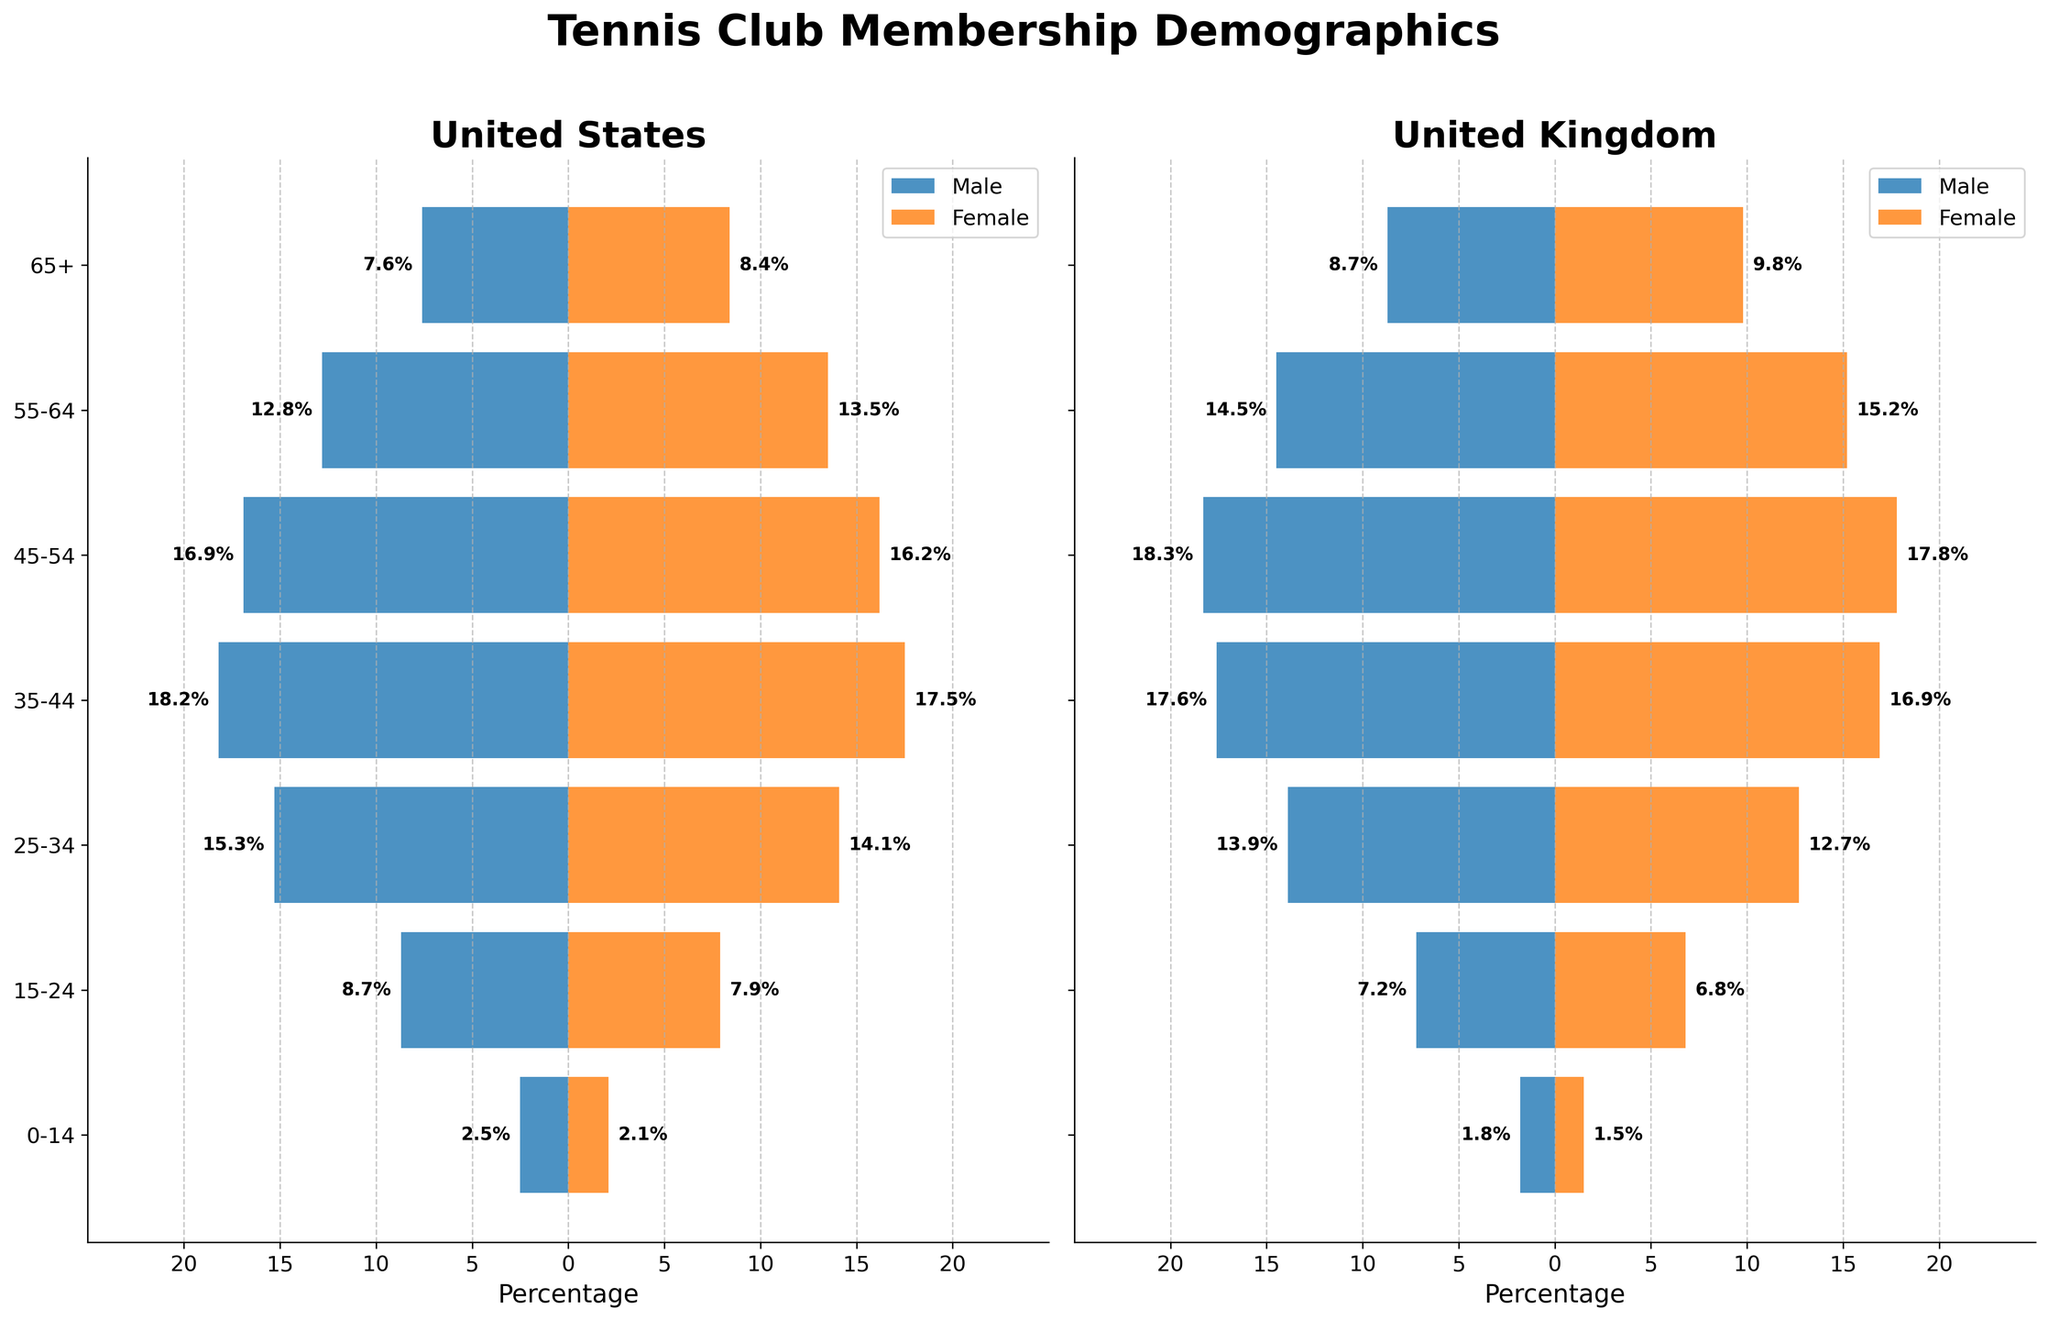What's the title of the figure? The title of the figure is located at the top center of the plot. It reads "Tennis Club Membership Demographics".
Answer: Tennis Club Membership Demographics Which country has a higher percentage of female members in the age group 35-44? To find the answer, compare the percentage of female members aged 35-44 in the United States and the United Kingdom. The United States has 17.5%, and the United Kingdom has 16.9%.
Answer: United States What is the total percentage of male and female tennis club members aged 45-54 in the United States? Add the percentages of male (16.9%) and female (16.2%) members aged 45-54. The total is 16.9 + 16.2 = 33.1.
Answer: 33.1% What is the difference in the percentage of male members aged 15-24 between the United States and the United Kingdom? Subtract the percentage of male members aged 15-24 in the United Kingdom (7.2%) from that in the United States (8.7%). The difference is 8.7 - 7.2 = 1.5.
Answer: 1.5% In the United Kingdom, which gender has a higher percentage in the age group 55-64? Compare the percentages of male and female members aged 55-64 in the United Kingdom. Males have 14.5%, and females have 15.2%.
Answer: Female What is the average percentage of female members in the United States across all age groups? Sum the percentages of female members across all age groups in the United States (2.1 + 7.9 + 14.1 + 17.5 + 16.2 + 13.5 + 8.4 = 79.7), then divide by the number of age groups (7). The average is 79.7 / 7 = 11.39.
Answer: 11.39% Which age group has the highest percentage of male members in the United Kingdom? Find the age group with the highest percentage value for male members in the United Kingdom. The highest percentage is 18.3% for the age group 45-54.
Answer: 45-54 What is the combined percentage of male members aged 25-34 in both the United States and the United Kingdom? Add the percentages of male members aged 25-34 in the United States (15.3%) and the United Kingdom (13.9%). The combined percentage is 15.3 + 13.9 = 29.2.
Answer: 29.2% Which country has a higher percentage of male members aged 65 and older? Compare the percentages of male members aged 65+ in the United States (7.6%) and the United Kingdom (8.7%).
Answer: United Kingdom 